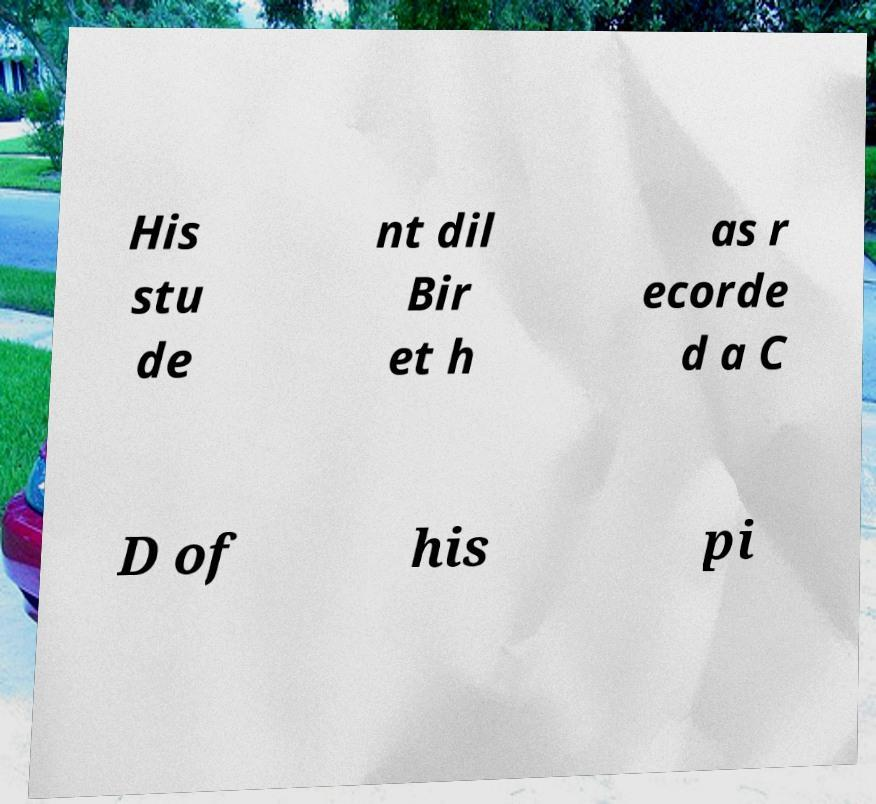For documentation purposes, I need the text within this image transcribed. Could you provide that? His stu de nt dil Bir et h as r ecorde d a C D of his pi 